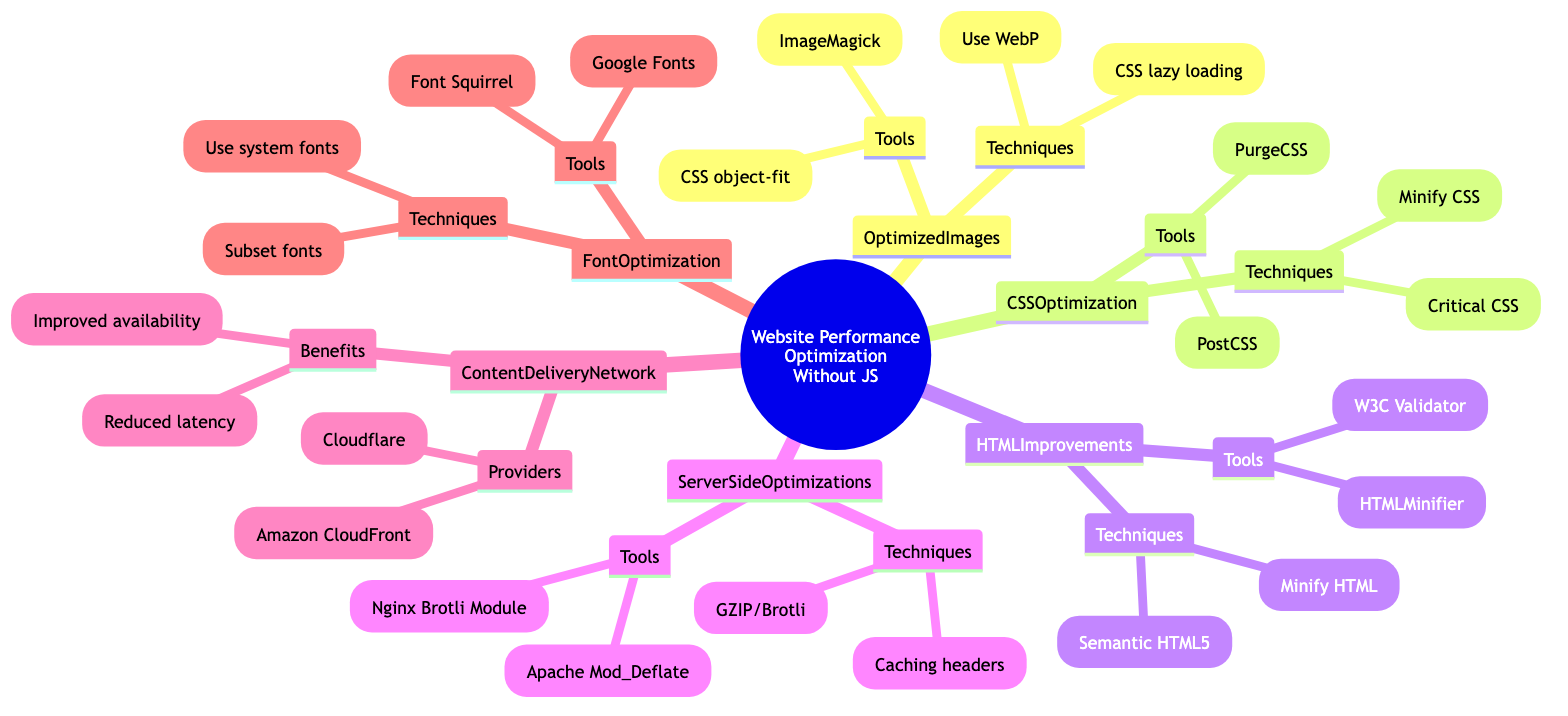What are two techniques under Optimized Images? Under the "Optimized Images" node, two techniques listed are "Use modern image formats like WebP" and "Implement lazy loading using CSS."
Answer: Use modern image formats like WebP, Implement lazy loading using CSS How many techniques are listed under CSS Optimization? The "CSS Optimization" node has two techniques mentioned: "Minify CSS files" and "Use critical CSS to prioritize above-the-fold content." Hence, there are two techniques.
Answer: 2 What tool is associated with HTML Minification? The "HTML Improvements" section lists "HTMLMinifier" as a tool associated with the technique of minifying HTML code.
Answer: HTMLMinifier Which provider is mentioned under Content Delivery Network? The "Content Delivery Network" section includes two providers, one of which is "Cloudflare."
Answer: Cloudflare What is one benefit of using a Content Delivery Network? One benefit mentioned under the "Content Delivery Network" is "Reduced latency."
Answer: Reduced latency Which technique is related to font optimization regarding system fonts? Under the "Font Optimization" section, the technique regarding system fonts is "Use system fonts when possible."
Answer: Use system fonts when possible Which server-side tool is used for GZIP compression? The "Server Side Optimizations" node lists "Apache Mod_Deflate" as the tool used for GZIP compression.
Answer: Apache Mod_Deflate What is a purpose of using critical CSS in CSS Optimization? "Use critical CSS to prioritize above-the-fold content" is a technique aimed at optimizing how the content is loaded and displayed for users quickly.
Answer: Prioritize above-the-fold content What tool can be used to remove unused CSS? The "CSS Optimization" section mentions "PurgeCSS" as a tool for removing unused CSS.
Answer: PurgeCSS 